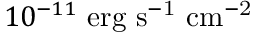Convert formula to latex. <formula><loc_0><loc_0><loc_500><loc_500>1 0 ^ { - 1 1 } { \ e r g \ s ^ { - 1 } \ c m ^ { - 2 } }</formula> 